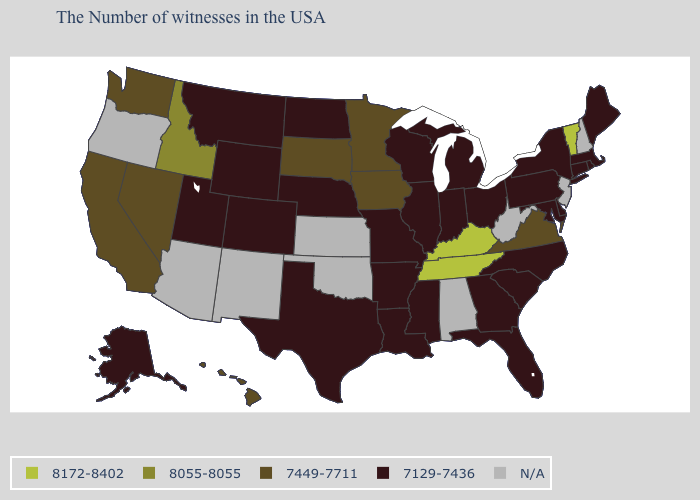What is the value of Nevada?
Keep it brief. 7449-7711. What is the highest value in the USA?
Answer briefly. 8172-8402. Does Maryland have the highest value in the South?
Short answer required. No. What is the highest value in the USA?
Write a very short answer. 8172-8402. How many symbols are there in the legend?
Keep it brief. 5. Which states have the lowest value in the USA?
Answer briefly. Maine, Massachusetts, Rhode Island, Connecticut, New York, Delaware, Maryland, Pennsylvania, North Carolina, South Carolina, Ohio, Florida, Georgia, Michigan, Indiana, Wisconsin, Illinois, Mississippi, Louisiana, Missouri, Arkansas, Nebraska, Texas, North Dakota, Wyoming, Colorado, Utah, Montana, Alaska. Does the first symbol in the legend represent the smallest category?
Be succinct. No. Does Louisiana have the lowest value in the South?
Quick response, please. Yes. What is the value of Maryland?
Write a very short answer. 7129-7436. Does Indiana have the lowest value in the USA?
Quick response, please. Yes. Does South Carolina have the highest value in the USA?
Short answer required. No. Among the states that border Alabama , which have the lowest value?
Quick response, please. Florida, Georgia, Mississippi. Which states have the lowest value in the West?
Concise answer only. Wyoming, Colorado, Utah, Montana, Alaska. 